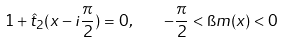<formula> <loc_0><loc_0><loc_500><loc_500>1 + \hat { t } _ { 2 } ( x - i \frac { \pi } { 2 } ) = 0 , \quad - \frac { \pi } { 2 } < \i m ( x ) < 0</formula> 